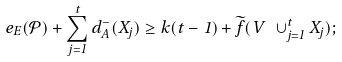Convert formula to latex. <formula><loc_0><loc_0><loc_500><loc_500>e _ { E } ( \mathcal { P } ) + \sum ^ { t } _ { j = 1 } d _ { A } ^ { - } ( X _ { j } ) \geq k ( t - 1 ) + \widetilde { f } ( V \ \cup _ { j = 1 } ^ { t } X _ { j } ) ;</formula> 